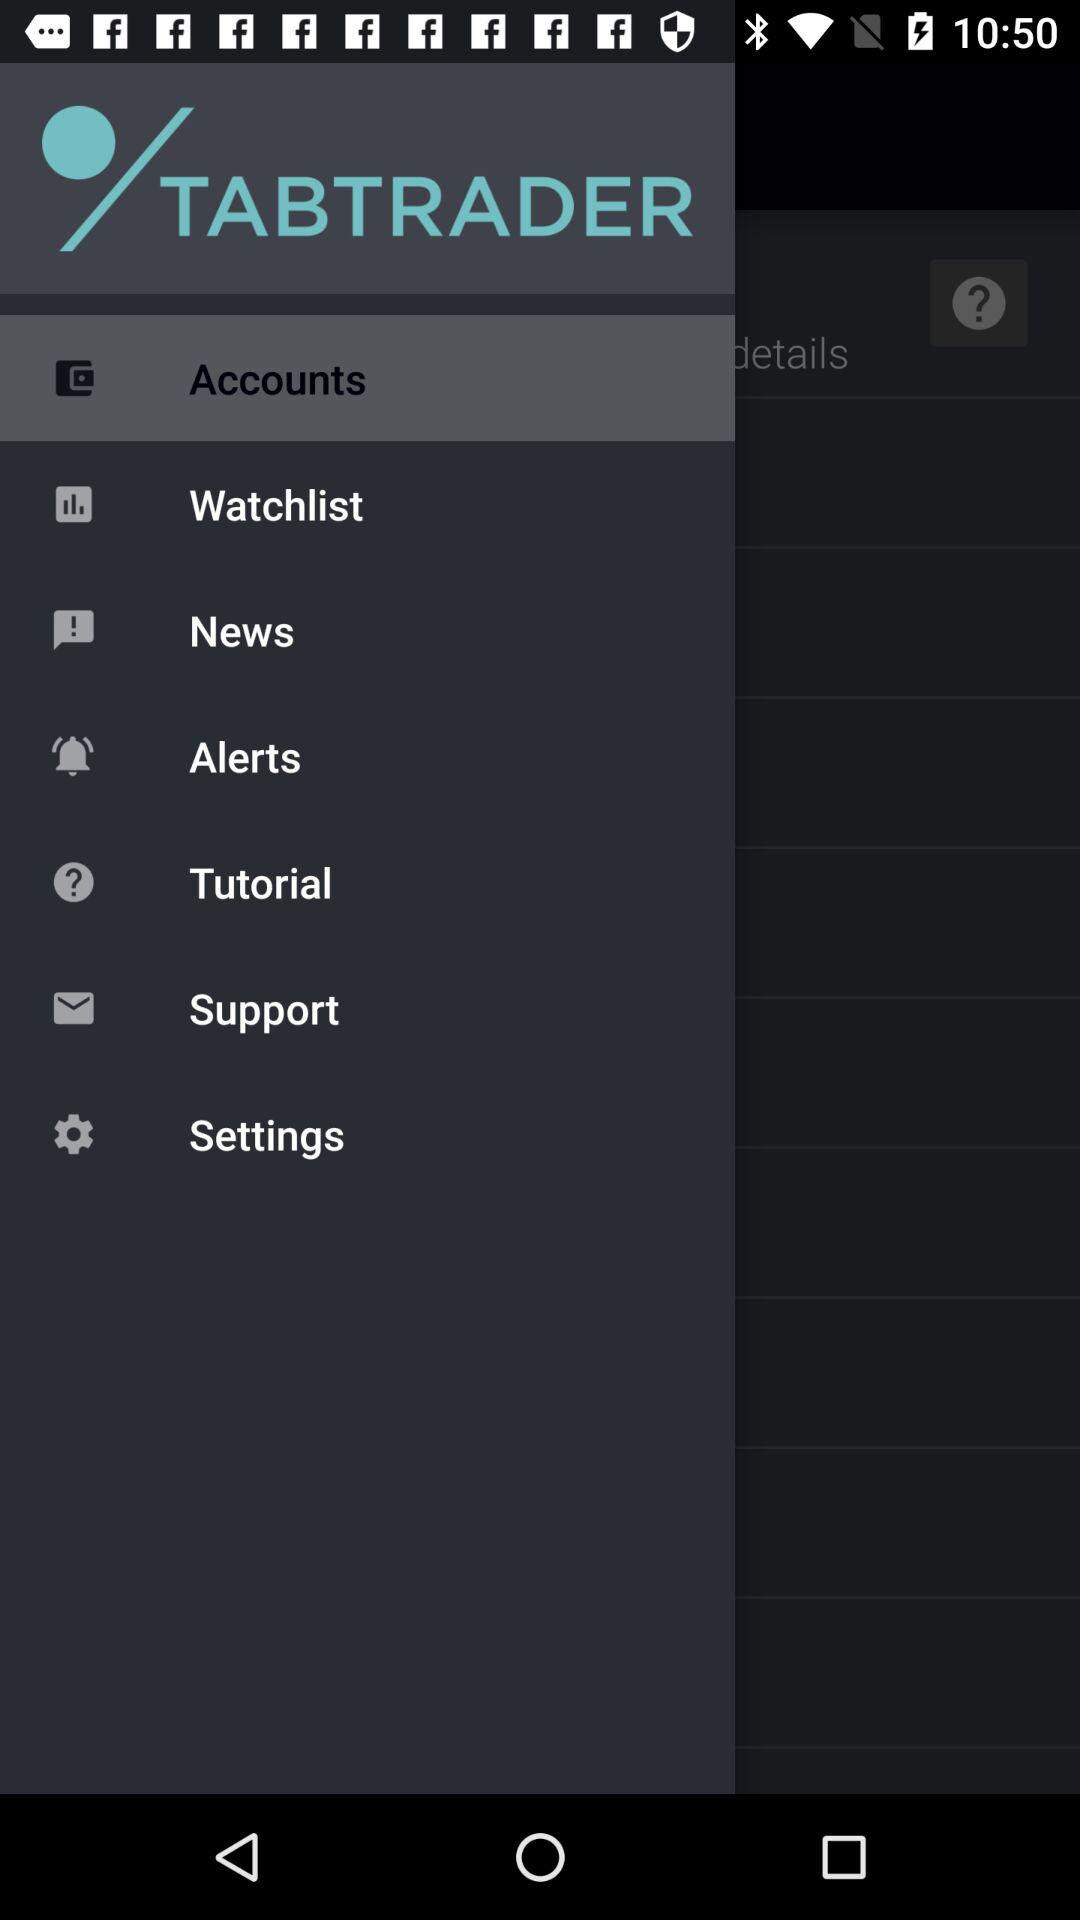Which item is selected? The selected item is "Accounts". 